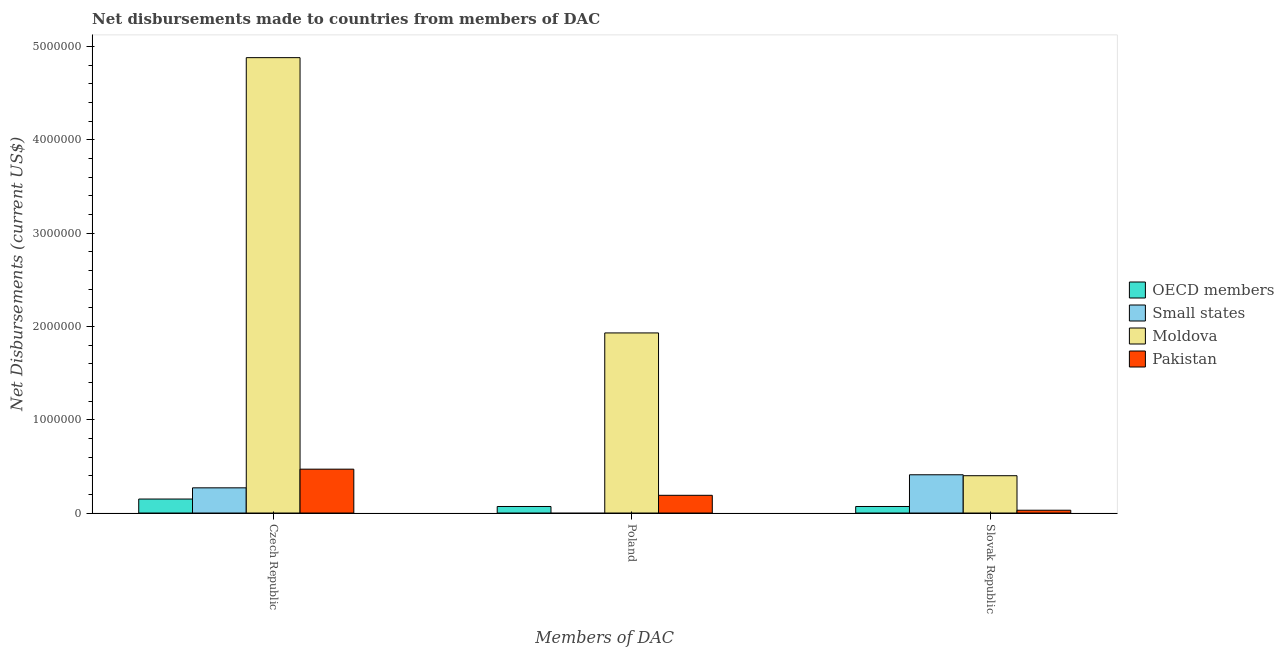How many different coloured bars are there?
Offer a terse response. 4. Are the number of bars per tick equal to the number of legend labels?
Offer a very short reply. No. What is the label of the 3rd group of bars from the left?
Keep it short and to the point. Slovak Republic. What is the net disbursements made by poland in Pakistan?
Offer a terse response. 1.90e+05. Across all countries, what is the maximum net disbursements made by czech republic?
Your response must be concise. 4.88e+06. Across all countries, what is the minimum net disbursements made by slovak republic?
Provide a short and direct response. 3.00e+04. In which country was the net disbursements made by slovak republic maximum?
Your answer should be very brief. Small states. What is the total net disbursements made by czech republic in the graph?
Offer a very short reply. 5.77e+06. What is the difference between the net disbursements made by czech republic in Pakistan and that in Small states?
Make the answer very short. 2.00e+05. What is the difference between the net disbursements made by czech republic in Moldova and the net disbursements made by poland in Small states?
Offer a terse response. 4.88e+06. What is the average net disbursements made by poland per country?
Make the answer very short. 5.48e+05. What is the difference between the net disbursements made by poland and net disbursements made by slovak republic in OECD members?
Your response must be concise. 0. What is the ratio of the net disbursements made by poland in Moldova to that in Pakistan?
Offer a terse response. 10.16. Is the difference between the net disbursements made by slovak republic in Small states and Pakistan greater than the difference between the net disbursements made by czech republic in Small states and Pakistan?
Offer a terse response. Yes. What is the difference between the highest and the second highest net disbursements made by slovak republic?
Offer a terse response. 10000. What is the difference between the highest and the lowest net disbursements made by czech republic?
Offer a very short reply. 4.73e+06. In how many countries, is the net disbursements made by poland greater than the average net disbursements made by poland taken over all countries?
Offer a terse response. 1. Is it the case that in every country, the sum of the net disbursements made by czech republic and net disbursements made by poland is greater than the net disbursements made by slovak republic?
Your answer should be compact. No. What is the difference between two consecutive major ticks on the Y-axis?
Make the answer very short. 1.00e+06. Are the values on the major ticks of Y-axis written in scientific E-notation?
Keep it short and to the point. No. Does the graph contain grids?
Provide a succinct answer. No. What is the title of the graph?
Make the answer very short. Net disbursements made to countries from members of DAC. Does "St. Kitts and Nevis" appear as one of the legend labels in the graph?
Provide a short and direct response. No. What is the label or title of the X-axis?
Offer a very short reply. Members of DAC. What is the label or title of the Y-axis?
Provide a short and direct response. Net Disbursements (current US$). What is the Net Disbursements (current US$) of Small states in Czech Republic?
Give a very brief answer. 2.70e+05. What is the Net Disbursements (current US$) of Moldova in Czech Republic?
Make the answer very short. 4.88e+06. What is the Net Disbursements (current US$) of OECD members in Poland?
Keep it short and to the point. 7.00e+04. What is the Net Disbursements (current US$) in Moldova in Poland?
Give a very brief answer. 1.93e+06. What is the Net Disbursements (current US$) of Small states in Slovak Republic?
Ensure brevity in your answer.  4.10e+05. What is the Net Disbursements (current US$) in Moldova in Slovak Republic?
Make the answer very short. 4.00e+05. What is the Net Disbursements (current US$) of Pakistan in Slovak Republic?
Offer a terse response. 3.00e+04. Across all Members of DAC, what is the maximum Net Disbursements (current US$) in OECD members?
Keep it short and to the point. 1.50e+05. Across all Members of DAC, what is the maximum Net Disbursements (current US$) of Small states?
Offer a terse response. 4.10e+05. Across all Members of DAC, what is the maximum Net Disbursements (current US$) of Moldova?
Make the answer very short. 4.88e+06. Across all Members of DAC, what is the minimum Net Disbursements (current US$) in OECD members?
Your response must be concise. 7.00e+04. Across all Members of DAC, what is the minimum Net Disbursements (current US$) in Small states?
Your answer should be very brief. 0. What is the total Net Disbursements (current US$) of Small states in the graph?
Provide a succinct answer. 6.80e+05. What is the total Net Disbursements (current US$) in Moldova in the graph?
Offer a very short reply. 7.21e+06. What is the total Net Disbursements (current US$) in Pakistan in the graph?
Provide a succinct answer. 6.90e+05. What is the difference between the Net Disbursements (current US$) of OECD members in Czech Republic and that in Poland?
Provide a short and direct response. 8.00e+04. What is the difference between the Net Disbursements (current US$) in Moldova in Czech Republic and that in Poland?
Ensure brevity in your answer.  2.95e+06. What is the difference between the Net Disbursements (current US$) of Pakistan in Czech Republic and that in Poland?
Offer a terse response. 2.80e+05. What is the difference between the Net Disbursements (current US$) of Small states in Czech Republic and that in Slovak Republic?
Your response must be concise. -1.40e+05. What is the difference between the Net Disbursements (current US$) of Moldova in Czech Republic and that in Slovak Republic?
Your response must be concise. 4.48e+06. What is the difference between the Net Disbursements (current US$) of Pakistan in Czech Republic and that in Slovak Republic?
Provide a short and direct response. 4.40e+05. What is the difference between the Net Disbursements (current US$) of Moldova in Poland and that in Slovak Republic?
Keep it short and to the point. 1.53e+06. What is the difference between the Net Disbursements (current US$) of Pakistan in Poland and that in Slovak Republic?
Give a very brief answer. 1.60e+05. What is the difference between the Net Disbursements (current US$) of OECD members in Czech Republic and the Net Disbursements (current US$) of Moldova in Poland?
Your answer should be compact. -1.78e+06. What is the difference between the Net Disbursements (current US$) in Small states in Czech Republic and the Net Disbursements (current US$) in Moldova in Poland?
Make the answer very short. -1.66e+06. What is the difference between the Net Disbursements (current US$) of Small states in Czech Republic and the Net Disbursements (current US$) of Pakistan in Poland?
Ensure brevity in your answer.  8.00e+04. What is the difference between the Net Disbursements (current US$) in Moldova in Czech Republic and the Net Disbursements (current US$) in Pakistan in Poland?
Your answer should be compact. 4.69e+06. What is the difference between the Net Disbursements (current US$) of OECD members in Czech Republic and the Net Disbursements (current US$) of Pakistan in Slovak Republic?
Offer a terse response. 1.20e+05. What is the difference between the Net Disbursements (current US$) in Small states in Czech Republic and the Net Disbursements (current US$) in Pakistan in Slovak Republic?
Your answer should be very brief. 2.40e+05. What is the difference between the Net Disbursements (current US$) of Moldova in Czech Republic and the Net Disbursements (current US$) of Pakistan in Slovak Republic?
Your answer should be very brief. 4.85e+06. What is the difference between the Net Disbursements (current US$) of OECD members in Poland and the Net Disbursements (current US$) of Small states in Slovak Republic?
Offer a very short reply. -3.40e+05. What is the difference between the Net Disbursements (current US$) of OECD members in Poland and the Net Disbursements (current US$) of Moldova in Slovak Republic?
Provide a short and direct response. -3.30e+05. What is the difference between the Net Disbursements (current US$) of Moldova in Poland and the Net Disbursements (current US$) of Pakistan in Slovak Republic?
Your answer should be very brief. 1.90e+06. What is the average Net Disbursements (current US$) of OECD members per Members of DAC?
Give a very brief answer. 9.67e+04. What is the average Net Disbursements (current US$) in Small states per Members of DAC?
Your answer should be compact. 2.27e+05. What is the average Net Disbursements (current US$) in Moldova per Members of DAC?
Your answer should be compact. 2.40e+06. What is the difference between the Net Disbursements (current US$) in OECD members and Net Disbursements (current US$) in Small states in Czech Republic?
Your response must be concise. -1.20e+05. What is the difference between the Net Disbursements (current US$) of OECD members and Net Disbursements (current US$) of Moldova in Czech Republic?
Offer a terse response. -4.73e+06. What is the difference between the Net Disbursements (current US$) of OECD members and Net Disbursements (current US$) of Pakistan in Czech Republic?
Your answer should be very brief. -3.20e+05. What is the difference between the Net Disbursements (current US$) in Small states and Net Disbursements (current US$) in Moldova in Czech Republic?
Ensure brevity in your answer.  -4.61e+06. What is the difference between the Net Disbursements (current US$) in Moldova and Net Disbursements (current US$) in Pakistan in Czech Republic?
Keep it short and to the point. 4.41e+06. What is the difference between the Net Disbursements (current US$) in OECD members and Net Disbursements (current US$) in Moldova in Poland?
Your response must be concise. -1.86e+06. What is the difference between the Net Disbursements (current US$) in OECD members and Net Disbursements (current US$) in Pakistan in Poland?
Make the answer very short. -1.20e+05. What is the difference between the Net Disbursements (current US$) in Moldova and Net Disbursements (current US$) in Pakistan in Poland?
Ensure brevity in your answer.  1.74e+06. What is the difference between the Net Disbursements (current US$) of OECD members and Net Disbursements (current US$) of Small states in Slovak Republic?
Offer a terse response. -3.40e+05. What is the difference between the Net Disbursements (current US$) in OECD members and Net Disbursements (current US$) in Moldova in Slovak Republic?
Provide a short and direct response. -3.30e+05. What is the difference between the Net Disbursements (current US$) of Small states and Net Disbursements (current US$) of Moldova in Slovak Republic?
Make the answer very short. 10000. What is the ratio of the Net Disbursements (current US$) in OECD members in Czech Republic to that in Poland?
Give a very brief answer. 2.14. What is the ratio of the Net Disbursements (current US$) in Moldova in Czech Republic to that in Poland?
Your answer should be very brief. 2.53. What is the ratio of the Net Disbursements (current US$) in Pakistan in Czech Republic to that in Poland?
Provide a succinct answer. 2.47. What is the ratio of the Net Disbursements (current US$) in OECD members in Czech Republic to that in Slovak Republic?
Ensure brevity in your answer.  2.14. What is the ratio of the Net Disbursements (current US$) of Small states in Czech Republic to that in Slovak Republic?
Provide a short and direct response. 0.66. What is the ratio of the Net Disbursements (current US$) of Pakistan in Czech Republic to that in Slovak Republic?
Your answer should be very brief. 15.67. What is the ratio of the Net Disbursements (current US$) of OECD members in Poland to that in Slovak Republic?
Provide a succinct answer. 1. What is the ratio of the Net Disbursements (current US$) of Moldova in Poland to that in Slovak Republic?
Give a very brief answer. 4.83. What is the ratio of the Net Disbursements (current US$) in Pakistan in Poland to that in Slovak Republic?
Your answer should be very brief. 6.33. What is the difference between the highest and the second highest Net Disbursements (current US$) in Moldova?
Your response must be concise. 2.95e+06. What is the difference between the highest and the second highest Net Disbursements (current US$) in Pakistan?
Provide a short and direct response. 2.80e+05. What is the difference between the highest and the lowest Net Disbursements (current US$) in Moldova?
Your answer should be very brief. 4.48e+06. What is the difference between the highest and the lowest Net Disbursements (current US$) in Pakistan?
Give a very brief answer. 4.40e+05. 